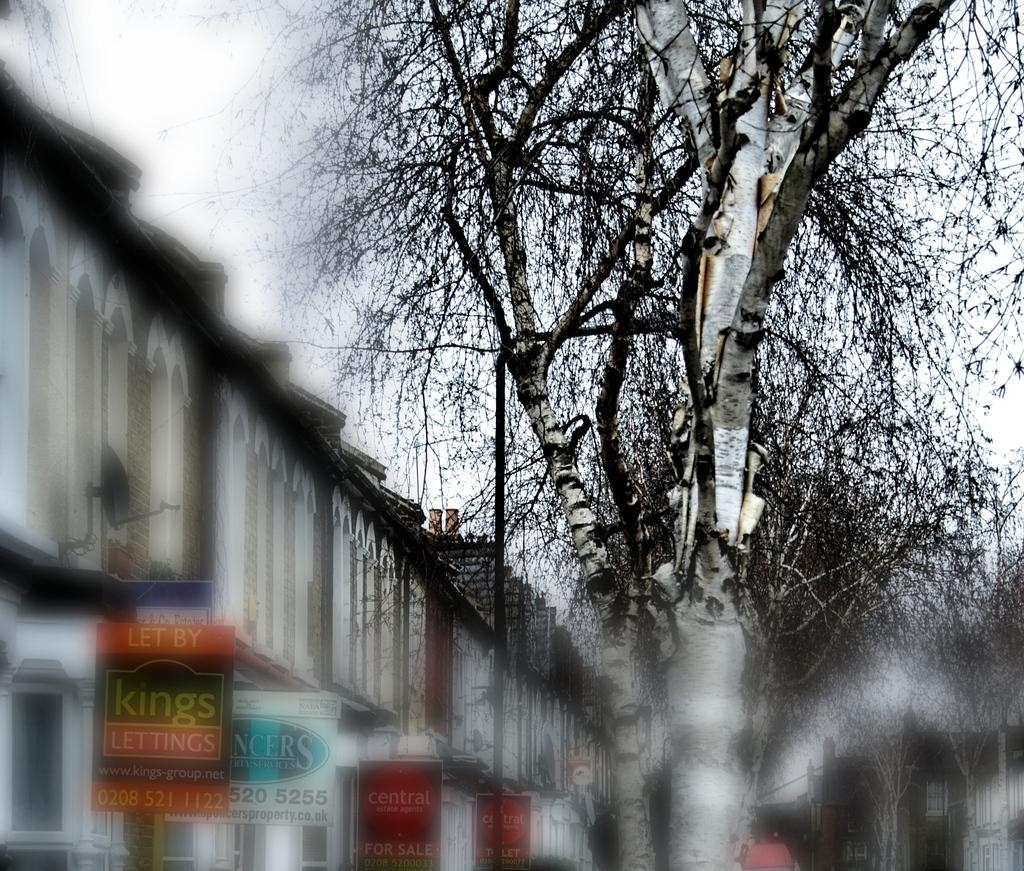<image>
Create a compact narrative representing the image presented. On a gloomy day the 3rd sign on the building says "Central Estate Agents For Sale". 